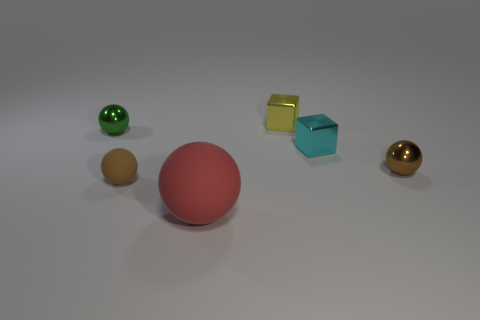There is a brown ball that is in front of the small brown metallic sphere; what is its size?
Make the answer very short. Small. How many other objects are there of the same color as the large thing?
Make the answer very short. 0. There is a brown ball right of the tiny brown thing in front of the brown metallic thing; what is it made of?
Offer a very short reply. Metal. There is a metal ball that is to the right of the tiny cyan metallic thing; is it the same color as the small matte ball?
Provide a succinct answer. Yes. What number of other objects have the same shape as the tiny cyan object?
Offer a very short reply. 1. Is there a tiny brown thing that is in front of the metallic cube behind the small sphere that is on the left side of the small brown rubber thing?
Your answer should be very brief. Yes. Does the cube to the right of the yellow block have the same size as the big rubber object?
Offer a terse response. No. What number of cyan metal cubes have the same size as the brown metal thing?
Ensure brevity in your answer.  1. The object that is the same color as the small rubber sphere is what size?
Your response must be concise. Small. What shape is the yellow thing?
Offer a very short reply. Cube. 